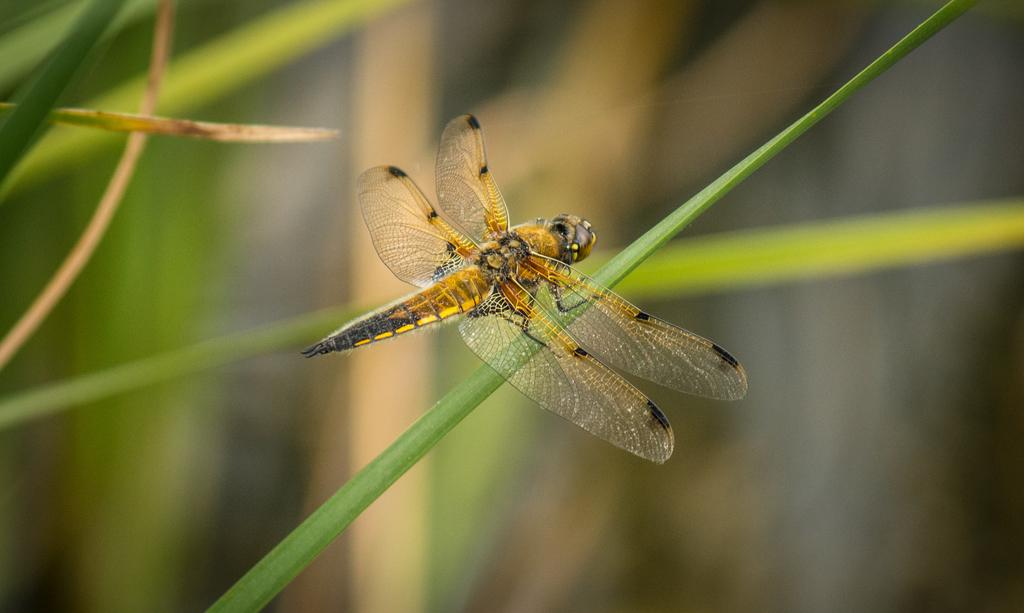What is present in the image? There is a fly in the image. Where is the fly located? The fly is on a plant. What type of power does the carpenter use to twist the fly in the image? There is no carpenter or any indication of twisting in the image; it only features a fly on a plant. 